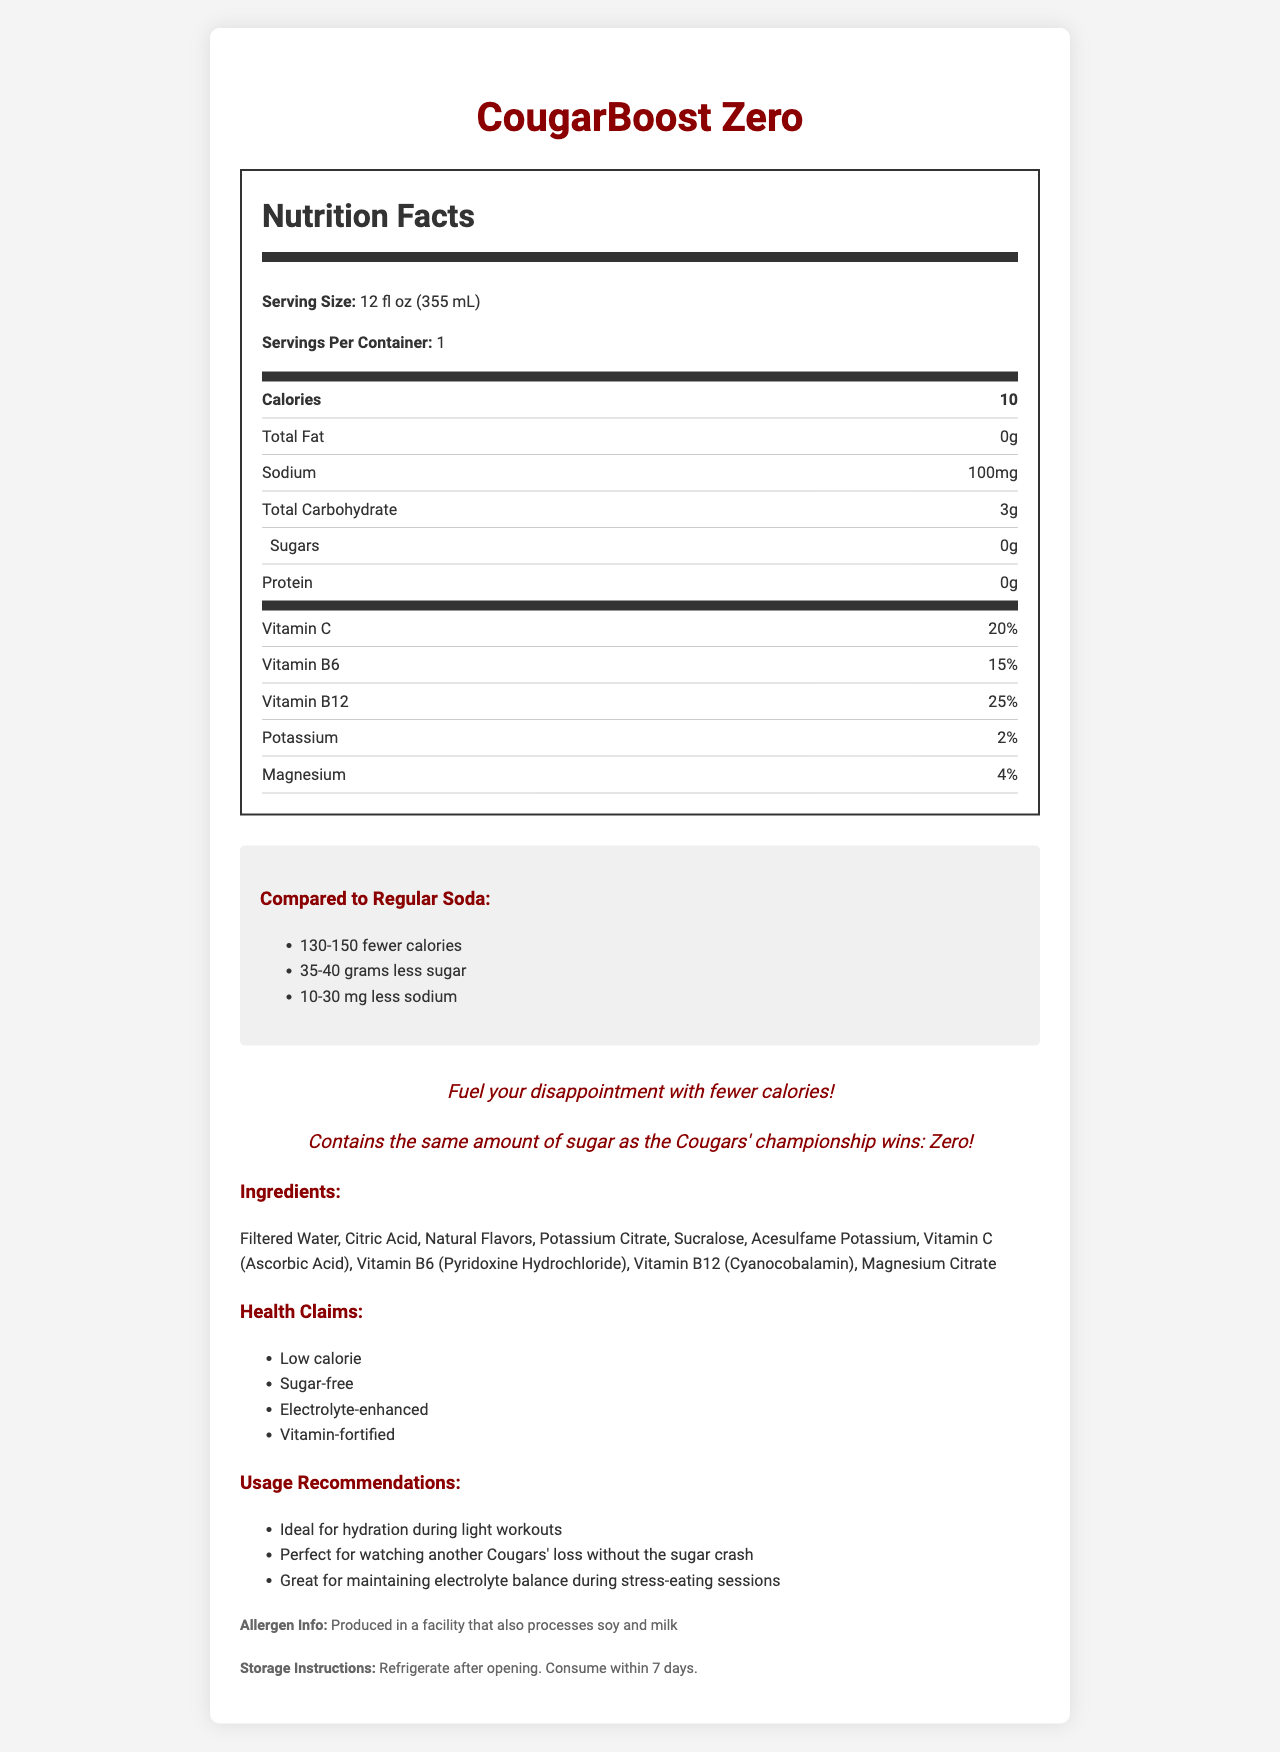what is the serving size? The serving size is clearly listed under the "Nutrition Facts" section at the beginning.
Answer: 12 fl oz (355 mL) what is the calorie count of CougarBoost Zero? The calorie count is listed in bold within the "Nutrition Facts" section.
Answer: 10 how much sodium does CougarBoost Zero contain? The sodium content is listed in the "Nutrition Facts" table under the "Sodium" row.
Answer: 100 mg compare the sugar content of CougarBoost Zero to regular sodas. The comparison section states that CougarBoost Zero has 35-40 grams less sugar than regular sodas.
Answer: CougarBoost Zero contains 35-40 grams less sugar what percentage of Vitamin C is in CougarBoost Zero? The percentage of Vitamin C is listed in the "Nutrition Facts" table under the "Vitamin C" row.
Answer: 20% which vitamin is present in the highest percentage in CougarBoost Zero? A. Vitamin C B. Vitamin B6 C. Vitamin B12 D. Potassium Vitamin B12 has a percentage of 25%, which is higher than the percentages of the other vitamins listed.
Answer: C how should you store CougarBoost Zero after opening? A. Store in a cool, dry place B. Keep in the original packaging C. Refrigerate and consume within 7 days D. Store in the freezer The storage instructions specify refrigeration and consumption within 7 days.
Answer: C is CougarBoost Zero produced in a facility that processes allergens? The allergen information states that it is produced in a facility that processes soy and milk.
Answer: Yes summarize the main benefits of CougarBoost Zero. The document emphasizes its low calorie, sugar-free nature, the presence of vitamins and electrolytes, and its recommended uses for hydration and recovery.
Answer: CougarBoost Zero is a low-calorie, sugar-free sports drink that contains essential vitamins and electrolytes, making it ideal for hydration during light workouts and for maintaining electrolyte balance. what is the tagline used to tie CougarBoost Zero to the Houston Cougars' performance? The document includes the tagline in a fun-fact section.
Answer: Fuel your disappointment with fewer calories! how does the sodium content of CougarBoost Zero compare to regular sodas? The comparison section notes that CougarBoost Zero has 10-30 mg less sodium than regular sodas.
Answer: CougarBoost Zero contains 10-30 mg less sodium than regular sodas list two ingredients found in CougarBoost Zero. Two of the listed ingredients include Filtered Water and Citric Acid.
Answer: Filtered Water, Citric Acid what is the protein content in CougarBoost Zero? The "Nutrition Facts" table states that the protein content is 0 grams.
Answer: 0 g does CougarBoost Zero contain any sugar? The document clearly states that CougarBoost Zero contains 0 grams of sugar.
Answer: No what are the suggested uses of CougarBoost Zero? The usage recommendations section outlines these specific scenarios.
Answer: For hydration during light workouts, watching a Cougars' game, and maintaining electrolyte balance during stress-eating. what is the connection between the sugar content of CougarBoost Zero and the Houston Cougars' championship wins? The fun-fact section makes this humorous comparison.
Answer: Contains the same amount of sugar as the Cougars' championship wins: Zero! what is the source of magnesium in CougarBoost Zero? The ingredient list includes Magnesium Citrate as the source of magnesium.
Answer: Magnesium Citrate what's the exact number of fewer calories CougarBoost Zero has compared to regular sodas? The document states a range of 130-150 fewer calories but does not provide an exact number.
Answer: Cannot be determined 